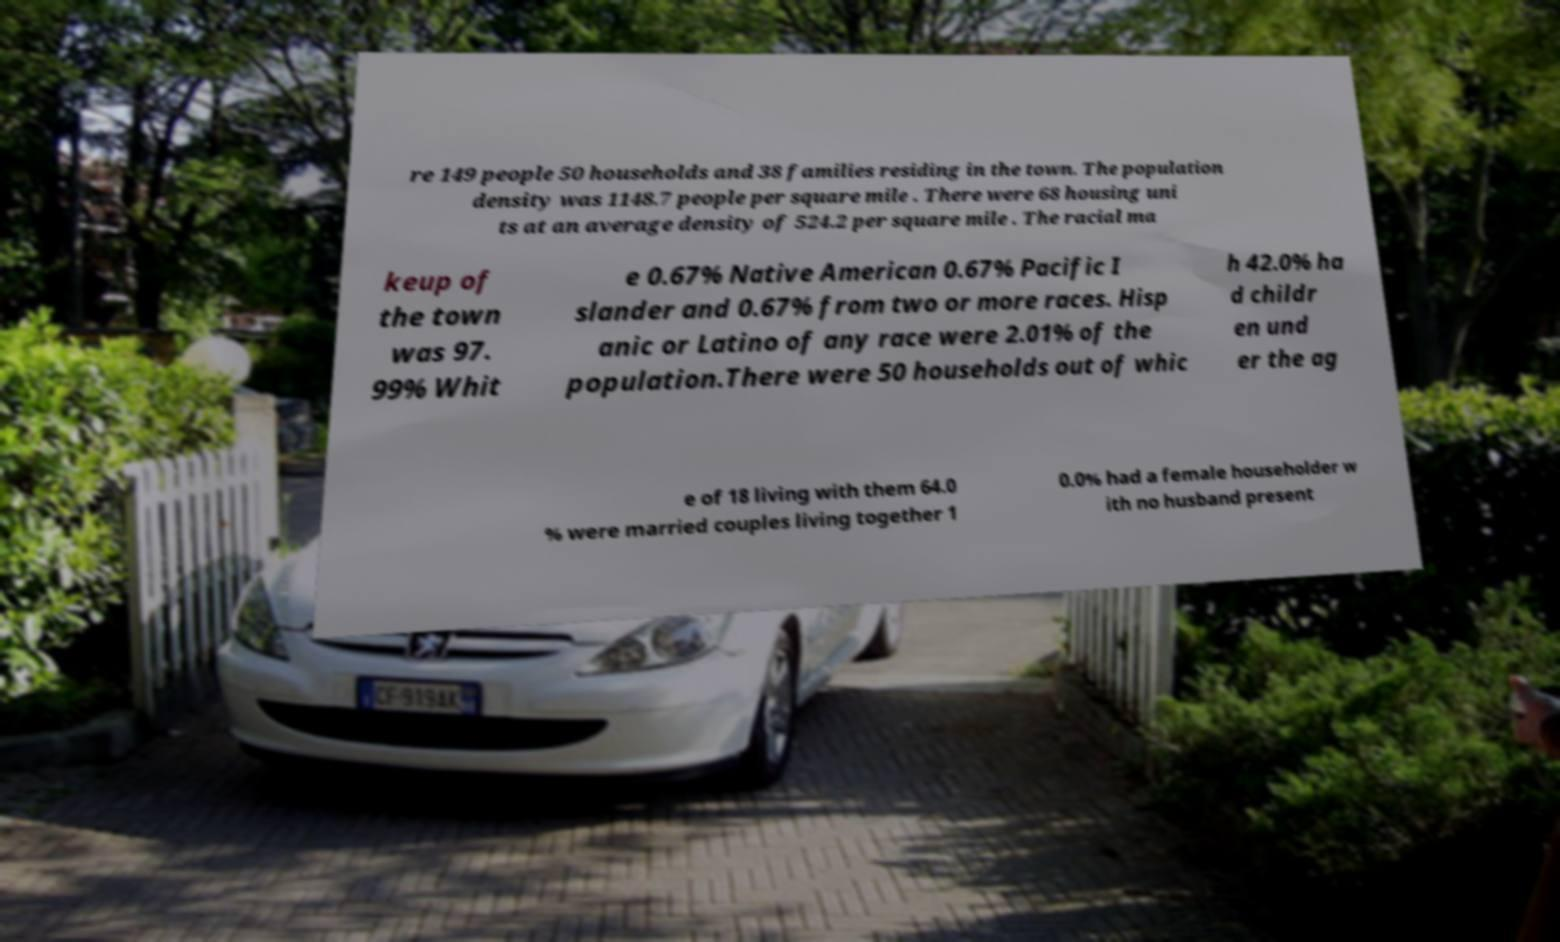Could you extract and type out the text from this image? re 149 people 50 households and 38 families residing in the town. The population density was 1148.7 people per square mile . There were 68 housing uni ts at an average density of 524.2 per square mile . The racial ma keup of the town was 97. 99% Whit e 0.67% Native American 0.67% Pacific I slander and 0.67% from two or more races. Hisp anic or Latino of any race were 2.01% of the population.There were 50 households out of whic h 42.0% ha d childr en und er the ag e of 18 living with them 64.0 % were married couples living together 1 0.0% had a female householder w ith no husband present 